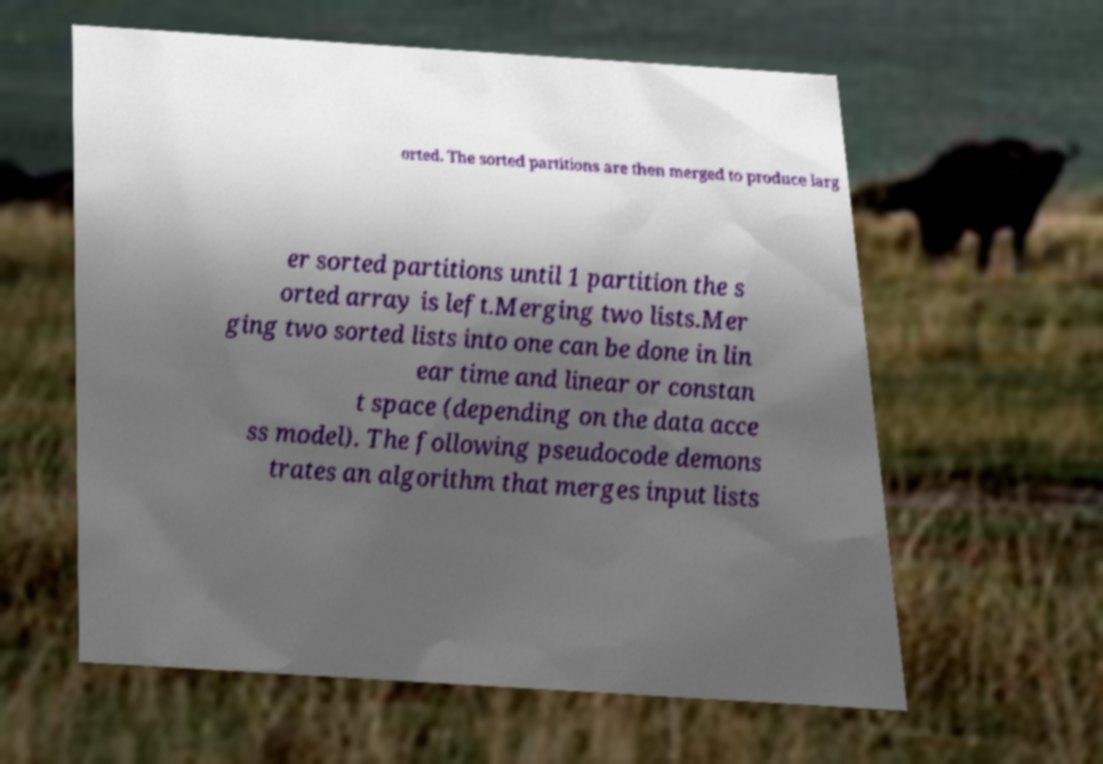Could you assist in decoding the text presented in this image and type it out clearly? orted. The sorted partitions are then merged to produce larg er sorted partitions until 1 partition the s orted array is left.Merging two lists.Mer ging two sorted lists into one can be done in lin ear time and linear or constan t space (depending on the data acce ss model). The following pseudocode demons trates an algorithm that merges input lists 